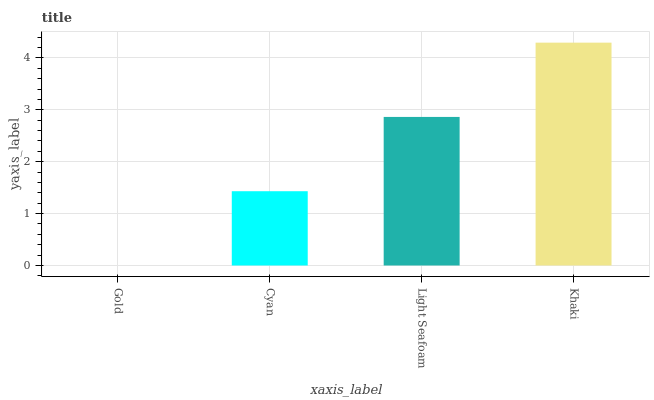Is Gold the minimum?
Answer yes or no. Yes. Is Khaki the maximum?
Answer yes or no. Yes. Is Cyan the minimum?
Answer yes or no. No. Is Cyan the maximum?
Answer yes or no. No. Is Cyan greater than Gold?
Answer yes or no. Yes. Is Gold less than Cyan?
Answer yes or no. Yes. Is Gold greater than Cyan?
Answer yes or no. No. Is Cyan less than Gold?
Answer yes or no. No. Is Light Seafoam the high median?
Answer yes or no. Yes. Is Cyan the low median?
Answer yes or no. Yes. Is Khaki the high median?
Answer yes or no. No. Is Gold the low median?
Answer yes or no. No. 